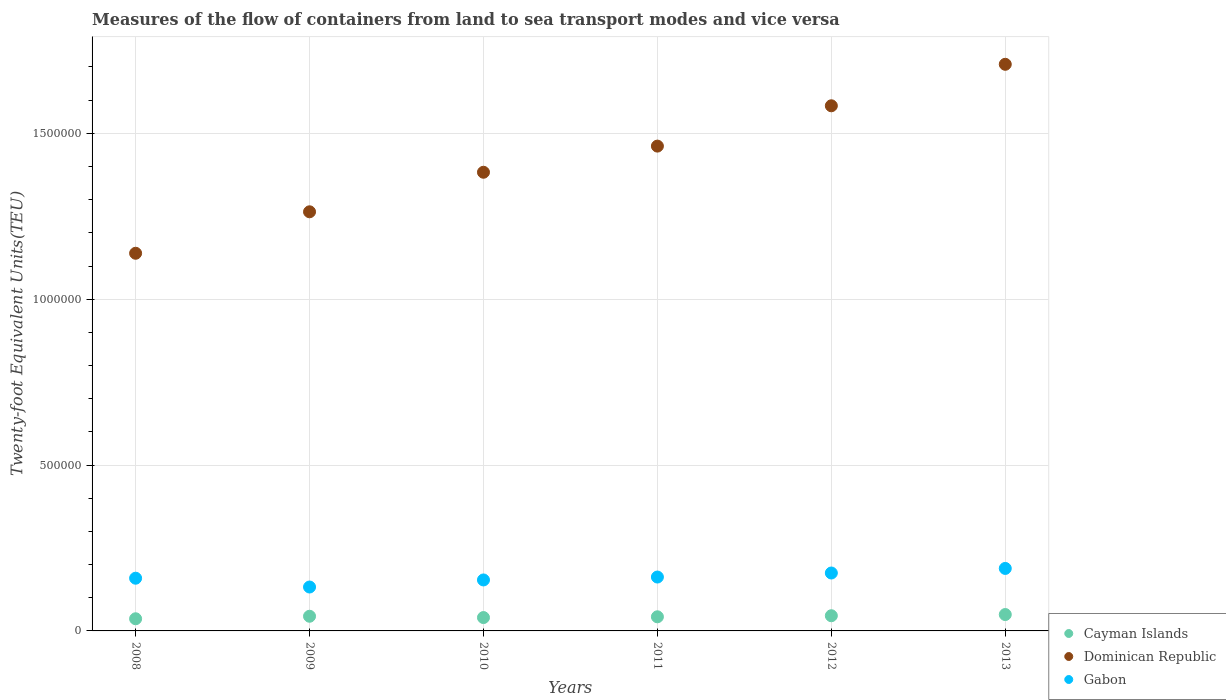How many different coloured dotlines are there?
Offer a very short reply. 3. Is the number of dotlines equal to the number of legend labels?
Offer a very short reply. Yes. What is the container port traffic in Cayman Islands in 2011?
Provide a succinct answer. 4.26e+04. Across all years, what is the maximum container port traffic in Gabon?
Keep it short and to the point. 1.88e+05. Across all years, what is the minimum container port traffic in Cayman Islands?
Provide a succinct answer. 3.66e+04. In which year was the container port traffic in Cayman Islands minimum?
Provide a succinct answer. 2008. What is the total container port traffic in Dominican Republic in the graph?
Your answer should be very brief. 8.54e+06. What is the difference between the container port traffic in Dominican Republic in 2009 and that in 2011?
Your answer should be very brief. -1.98e+05. What is the difference between the container port traffic in Dominican Republic in 2011 and the container port traffic in Cayman Islands in 2008?
Ensure brevity in your answer.  1.42e+06. What is the average container port traffic in Gabon per year?
Ensure brevity in your answer.  1.62e+05. In the year 2010, what is the difference between the container port traffic in Cayman Islands and container port traffic in Gabon?
Offer a terse response. -1.13e+05. What is the ratio of the container port traffic in Dominican Republic in 2010 to that in 2013?
Keep it short and to the point. 0.81. Is the container port traffic in Cayman Islands in 2008 less than that in 2010?
Offer a terse response. Yes. Is the difference between the container port traffic in Cayman Islands in 2008 and 2013 greater than the difference between the container port traffic in Gabon in 2008 and 2013?
Provide a short and direct response. Yes. What is the difference between the highest and the second highest container port traffic in Gabon?
Provide a short and direct response. 1.38e+04. What is the difference between the highest and the lowest container port traffic in Gabon?
Your answer should be compact. 5.60e+04. In how many years, is the container port traffic in Dominican Republic greater than the average container port traffic in Dominican Republic taken over all years?
Make the answer very short. 3. Is the sum of the container port traffic in Cayman Islands in 2011 and 2012 greater than the maximum container port traffic in Dominican Republic across all years?
Provide a short and direct response. No. Does the container port traffic in Dominican Republic monotonically increase over the years?
Make the answer very short. Yes. How many years are there in the graph?
Offer a very short reply. 6. What is the difference between two consecutive major ticks on the Y-axis?
Offer a terse response. 5.00e+05. Does the graph contain any zero values?
Offer a very short reply. No. Does the graph contain grids?
Give a very brief answer. Yes. How many legend labels are there?
Your answer should be very brief. 3. How are the legend labels stacked?
Keep it short and to the point. Vertical. What is the title of the graph?
Provide a short and direct response. Measures of the flow of containers from land to sea transport modes and vice versa. What is the label or title of the Y-axis?
Keep it short and to the point. Twenty-foot Equivalent Units(TEU). What is the Twenty-foot Equivalent Units(TEU) in Cayman Islands in 2008?
Your answer should be very brief. 3.66e+04. What is the Twenty-foot Equivalent Units(TEU) of Dominican Republic in 2008?
Make the answer very short. 1.14e+06. What is the Twenty-foot Equivalent Units(TEU) in Gabon in 2008?
Give a very brief answer. 1.59e+05. What is the Twenty-foot Equivalent Units(TEU) in Cayman Islands in 2009?
Your answer should be very brief. 4.42e+04. What is the Twenty-foot Equivalent Units(TEU) of Dominican Republic in 2009?
Your response must be concise. 1.26e+06. What is the Twenty-foot Equivalent Units(TEU) in Gabon in 2009?
Offer a very short reply. 1.32e+05. What is the Twenty-foot Equivalent Units(TEU) of Cayman Islands in 2010?
Offer a terse response. 4.03e+04. What is the Twenty-foot Equivalent Units(TEU) of Dominican Republic in 2010?
Make the answer very short. 1.38e+06. What is the Twenty-foot Equivalent Units(TEU) of Gabon in 2010?
Keep it short and to the point. 1.54e+05. What is the Twenty-foot Equivalent Units(TEU) in Cayman Islands in 2011?
Offer a terse response. 4.26e+04. What is the Twenty-foot Equivalent Units(TEU) of Dominican Republic in 2011?
Give a very brief answer. 1.46e+06. What is the Twenty-foot Equivalent Units(TEU) of Gabon in 2011?
Offer a very short reply. 1.62e+05. What is the Twenty-foot Equivalent Units(TEU) of Cayman Islands in 2012?
Your response must be concise. 4.58e+04. What is the Twenty-foot Equivalent Units(TEU) in Dominican Republic in 2012?
Ensure brevity in your answer.  1.58e+06. What is the Twenty-foot Equivalent Units(TEU) in Gabon in 2012?
Keep it short and to the point. 1.75e+05. What is the Twenty-foot Equivalent Units(TEU) in Cayman Islands in 2013?
Your answer should be very brief. 4.94e+04. What is the Twenty-foot Equivalent Units(TEU) in Dominican Republic in 2013?
Provide a short and direct response. 1.71e+06. What is the Twenty-foot Equivalent Units(TEU) in Gabon in 2013?
Offer a very short reply. 1.88e+05. Across all years, what is the maximum Twenty-foot Equivalent Units(TEU) in Cayman Islands?
Provide a succinct answer. 4.94e+04. Across all years, what is the maximum Twenty-foot Equivalent Units(TEU) of Dominican Republic?
Give a very brief answer. 1.71e+06. Across all years, what is the maximum Twenty-foot Equivalent Units(TEU) in Gabon?
Provide a short and direct response. 1.88e+05. Across all years, what is the minimum Twenty-foot Equivalent Units(TEU) in Cayman Islands?
Give a very brief answer. 3.66e+04. Across all years, what is the minimum Twenty-foot Equivalent Units(TEU) in Dominican Republic?
Your answer should be very brief. 1.14e+06. Across all years, what is the minimum Twenty-foot Equivalent Units(TEU) in Gabon?
Make the answer very short. 1.32e+05. What is the total Twenty-foot Equivalent Units(TEU) in Cayman Islands in the graph?
Provide a succinct answer. 2.59e+05. What is the total Twenty-foot Equivalent Units(TEU) in Dominican Republic in the graph?
Offer a terse response. 8.54e+06. What is the total Twenty-foot Equivalent Units(TEU) in Gabon in the graph?
Keep it short and to the point. 9.70e+05. What is the difference between the Twenty-foot Equivalent Units(TEU) of Cayman Islands in 2008 and that in 2009?
Your response must be concise. -7571. What is the difference between the Twenty-foot Equivalent Units(TEU) in Dominican Republic in 2008 and that in 2009?
Offer a terse response. -1.25e+05. What is the difference between the Twenty-foot Equivalent Units(TEU) of Gabon in 2008 and that in 2009?
Make the answer very short. 2.65e+04. What is the difference between the Twenty-foot Equivalent Units(TEU) of Cayman Islands in 2008 and that in 2010?
Offer a terse response. -3637. What is the difference between the Twenty-foot Equivalent Units(TEU) in Dominican Republic in 2008 and that in 2010?
Keep it short and to the point. -2.44e+05. What is the difference between the Twenty-foot Equivalent Units(TEU) of Gabon in 2008 and that in 2010?
Provide a short and direct response. 5227.04. What is the difference between the Twenty-foot Equivalent Units(TEU) of Cayman Islands in 2008 and that in 2011?
Your answer should be compact. -5933. What is the difference between the Twenty-foot Equivalent Units(TEU) of Dominican Republic in 2008 and that in 2011?
Your answer should be compact. -3.23e+05. What is the difference between the Twenty-foot Equivalent Units(TEU) in Gabon in 2008 and that in 2011?
Ensure brevity in your answer.  -3531.4. What is the difference between the Twenty-foot Equivalent Units(TEU) in Cayman Islands in 2008 and that in 2012?
Provide a short and direct response. -9126.27. What is the difference between the Twenty-foot Equivalent Units(TEU) in Dominican Republic in 2008 and that in 2012?
Make the answer very short. -4.45e+05. What is the difference between the Twenty-foot Equivalent Units(TEU) of Gabon in 2008 and that in 2012?
Your response must be concise. -1.57e+04. What is the difference between the Twenty-foot Equivalent Units(TEU) in Cayman Islands in 2008 and that in 2013?
Make the answer very short. -1.27e+04. What is the difference between the Twenty-foot Equivalent Units(TEU) in Dominican Republic in 2008 and that in 2013?
Provide a succinct answer. -5.70e+05. What is the difference between the Twenty-foot Equivalent Units(TEU) in Gabon in 2008 and that in 2013?
Give a very brief answer. -2.95e+04. What is the difference between the Twenty-foot Equivalent Units(TEU) of Cayman Islands in 2009 and that in 2010?
Your answer should be compact. 3934. What is the difference between the Twenty-foot Equivalent Units(TEU) in Dominican Republic in 2009 and that in 2010?
Your answer should be compact. -1.19e+05. What is the difference between the Twenty-foot Equivalent Units(TEU) in Gabon in 2009 and that in 2010?
Provide a short and direct response. -2.13e+04. What is the difference between the Twenty-foot Equivalent Units(TEU) in Cayman Islands in 2009 and that in 2011?
Your answer should be compact. 1638. What is the difference between the Twenty-foot Equivalent Units(TEU) in Dominican Republic in 2009 and that in 2011?
Offer a very short reply. -1.98e+05. What is the difference between the Twenty-foot Equivalent Units(TEU) in Gabon in 2009 and that in 2011?
Offer a terse response. -3.01e+04. What is the difference between the Twenty-foot Equivalent Units(TEU) of Cayman Islands in 2009 and that in 2012?
Offer a terse response. -1555.28. What is the difference between the Twenty-foot Equivalent Units(TEU) in Dominican Republic in 2009 and that in 2012?
Offer a terse response. -3.20e+05. What is the difference between the Twenty-foot Equivalent Units(TEU) of Gabon in 2009 and that in 2012?
Give a very brief answer. -4.22e+04. What is the difference between the Twenty-foot Equivalent Units(TEU) in Cayman Islands in 2009 and that in 2013?
Provide a succinct answer. -5171.13. What is the difference between the Twenty-foot Equivalent Units(TEU) of Dominican Republic in 2009 and that in 2013?
Offer a very short reply. -4.45e+05. What is the difference between the Twenty-foot Equivalent Units(TEU) of Gabon in 2009 and that in 2013?
Make the answer very short. -5.60e+04. What is the difference between the Twenty-foot Equivalent Units(TEU) of Cayman Islands in 2010 and that in 2011?
Provide a succinct answer. -2296. What is the difference between the Twenty-foot Equivalent Units(TEU) of Dominican Republic in 2010 and that in 2011?
Offer a terse response. -7.88e+04. What is the difference between the Twenty-foot Equivalent Units(TEU) in Gabon in 2010 and that in 2011?
Give a very brief answer. -8758.45. What is the difference between the Twenty-foot Equivalent Units(TEU) of Cayman Islands in 2010 and that in 2012?
Offer a terse response. -5489.27. What is the difference between the Twenty-foot Equivalent Units(TEU) in Dominican Republic in 2010 and that in 2012?
Provide a succinct answer. -2.00e+05. What is the difference between the Twenty-foot Equivalent Units(TEU) of Gabon in 2010 and that in 2012?
Your response must be concise. -2.09e+04. What is the difference between the Twenty-foot Equivalent Units(TEU) of Cayman Islands in 2010 and that in 2013?
Your answer should be compact. -9105.13. What is the difference between the Twenty-foot Equivalent Units(TEU) in Dominican Republic in 2010 and that in 2013?
Make the answer very short. -3.25e+05. What is the difference between the Twenty-foot Equivalent Units(TEU) of Gabon in 2010 and that in 2013?
Provide a succinct answer. -3.47e+04. What is the difference between the Twenty-foot Equivalent Units(TEU) of Cayman Islands in 2011 and that in 2012?
Offer a very short reply. -3193.28. What is the difference between the Twenty-foot Equivalent Units(TEU) in Dominican Republic in 2011 and that in 2012?
Your answer should be compact. -1.22e+05. What is the difference between the Twenty-foot Equivalent Units(TEU) in Gabon in 2011 and that in 2012?
Provide a succinct answer. -1.22e+04. What is the difference between the Twenty-foot Equivalent Units(TEU) of Cayman Islands in 2011 and that in 2013?
Make the answer very short. -6809.13. What is the difference between the Twenty-foot Equivalent Units(TEU) in Dominican Republic in 2011 and that in 2013?
Your answer should be very brief. -2.47e+05. What is the difference between the Twenty-foot Equivalent Units(TEU) of Gabon in 2011 and that in 2013?
Keep it short and to the point. -2.60e+04. What is the difference between the Twenty-foot Equivalent Units(TEU) in Cayman Islands in 2012 and that in 2013?
Your response must be concise. -3615.85. What is the difference between the Twenty-foot Equivalent Units(TEU) of Dominican Republic in 2012 and that in 2013?
Your response must be concise. -1.25e+05. What is the difference between the Twenty-foot Equivalent Units(TEU) of Gabon in 2012 and that in 2013?
Keep it short and to the point. -1.38e+04. What is the difference between the Twenty-foot Equivalent Units(TEU) of Cayman Islands in 2008 and the Twenty-foot Equivalent Units(TEU) of Dominican Republic in 2009?
Ensure brevity in your answer.  -1.23e+06. What is the difference between the Twenty-foot Equivalent Units(TEU) in Cayman Islands in 2008 and the Twenty-foot Equivalent Units(TEU) in Gabon in 2009?
Make the answer very short. -9.57e+04. What is the difference between the Twenty-foot Equivalent Units(TEU) of Dominican Republic in 2008 and the Twenty-foot Equivalent Units(TEU) of Gabon in 2009?
Keep it short and to the point. 1.01e+06. What is the difference between the Twenty-foot Equivalent Units(TEU) in Cayman Islands in 2008 and the Twenty-foot Equivalent Units(TEU) in Dominican Republic in 2010?
Your answer should be compact. -1.35e+06. What is the difference between the Twenty-foot Equivalent Units(TEU) of Cayman Islands in 2008 and the Twenty-foot Equivalent Units(TEU) of Gabon in 2010?
Give a very brief answer. -1.17e+05. What is the difference between the Twenty-foot Equivalent Units(TEU) in Dominican Republic in 2008 and the Twenty-foot Equivalent Units(TEU) in Gabon in 2010?
Provide a succinct answer. 9.85e+05. What is the difference between the Twenty-foot Equivalent Units(TEU) in Cayman Islands in 2008 and the Twenty-foot Equivalent Units(TEU) in Dominican Republic in 2011?
Ensure brevity in your answer.  -1.42e+06. What is the difference between the Twenty-foot Equivalent Units(TEU) of Cayman Islands in 2008 and the Twenty-foot Equivalent Units(TEU) of Gabon in 2011?
Make the answer very short. -1.26e+05. What is the difference between the Twenty-foot Equivalent Units(TEU) in Dominican Republic in 2008 and the Twenty-foot Equivalent Units(TEU) in Gabon in 2011?
Give a very brief answer. 9.76e+05. What is the difference between the Twenty-foot Equivalent Units(TEU) in Cayman Islands in 2008 and the Twenty-foot Equivalent Units(TEU) in Dominican Republic in 2012?
Make the answer very short. -1.55e+06. What is the difference between the Twenty-foot Equivalent Units(TEU) in Cayman Islands in 2008 and the Twenty-foot Equivalent Units(TEU) in Gabon in 2012?
Provide a short and direct response. -1.38e+05. What is the difference between the Twenty-foot Equivalent Units(TEU) of Dominican Republic in 2008 and the Twenty-foot Equivalent Units(TEU) of Gabon in 2012?
Make the answer very short. 9.64e+05. What is the difference between the Twenty-foot Equivalent Units(TEU) of Cayman Islands in 2008 and the Twenty-foot Equivalent Units(TEU) of Dominican Republic in 2013?
Your answer should be very brief. -1.67e+06. What is the difference between the Twenty-foot Equivalent Units(TEU) in Cayman Islands in 2008 and the Twenty-foot Equivalent Units(TEU) in Gabon in 2013?
Make the answer very short. -1.52e+05. What is the difference between the Twenty-foot Equivalent Units(TEU) in Dominican Republic in 2008 and the Twenty-foot Equivalent Units(TEU) in Gabon in 2013?
Give a very brief answer. 9.50e+05. What is the difference between the Twenty-foot Equivalent Units(TEU) in Cayman Islands in 2009 and the Twenty-foot Equivalent Units(TEU) in Dominican Republic in 2010?
Ensure brevity in your answer.  -1.34e+06. What is the difference between the Twenty-foot Equivalent Units(TEU) of Cayman Islands in 2009 and the Twenty-foot Equivalent Units(TEU) of Gabon in 2010?
Your answer should be compact. -1.09e+05. What is the difference between the Twenty-foot Equivalent Units(TEU) of Dominican Republic in 2009 and the Twenty-foot Equivalent Units(TEU) of Gabon in 2010?
Offer a very short reply. 1.11e+06. What is the difference between the Twenty-foot Equivalent Units(TEU) of Cayman Islands in 2009 and the Twenty-foot Equivalent Units(TEU) of Dominican Republic in 2011?
Offer a terse response. -1.42e+06. What is the difference between the Twenty-foot Equivalent Units(TEU) of Cayman Islands in 2009 and the Twenty-foot Equivalent Units(TEU) of Gabon in 2011?
Provide a short and direct response. -1.18e+05. What is the difference between the Twenty-foot Equivalent Units(TEU) of Dominican Republic in 2009 and the Twenty-foot Equivalent Units(TEU) of Gabon in 2011?
Your response must be concise. 1.10e+06. What is the difference between the Twenty-foot Equivalent Units(TEU) of Cayman Islands in 2009 and the Twenty-foot Equivalent Units(TEU) of Dominican Republic in 2012?
Offer a very short reply. -1.54e+06. What is the difference between the Twenty-foot Equivalent Units(TEU) in Cayman Islands in 2009 and the Twenty-foot Equivalent Units(TEU) in Gabon in 2012?
Provide a succinct answer. -1.30e+05. What is the difference between the Twenty-foot Equivalent Units(TEU) in Dominican Republic in 2009 and the Twenty-foot Equivalent Units(TEU) in Gabon in 2012?
Your answer should be very brief. 1.09e+06. What is the difference between the Twenty-foot Equivalent Units(TEU) in Cayman Islands in 2009 and the Twenty-foot Equivalent Units(TEU) in Dominican Republic in 2013?
Make the answer very short. -1.66e+06. What is the difference between the Twenty-foot Equivalent Units(TEU) in Cayman Islands in 2009 and the Twenty-foot Equivalent Units(TEU) in Gabon in 2013?
Your response must be concise. -1.44e+05. What is the difference between the Twenty-foot Equivalent Units(TEU) in Dominican Republic in 2009 and the Twenty-foot Equivalent Units(TEU) in Gabon in 2013?
Offer a very short reply. 1.08e+06. What is the difference between the Twenty-foot Equivalent Units(TEU) in Cayman Islands in 2010 and the Twenty-foot Equivalent Units(TEU) in Dominican Republic in 2011?
Ensure brevity in your answer.  -1.42e+06. What is the difference between the Twenty-foot Equivalent Units(TEU) in Cayman Islands in 2010 and the Twenty-foot Equivalent Units(TEU) in Gabon in 2011?
Keep it short and to the point. -1.22e+05. What is the difference between the Twenty-foot Equivalent Units(TEU) in Dominican Republic in 2010 and the Twenty-foot Equivalent Units(TEU) in Gabon in 2011?
Provide a succinct answer. 1.22e+06. What is the difference between the Twenty-foot Equivalent Units(TEU) in Cayman Islands in 2010 and the Twenty-foot Equivalent Units(TEU) in Dominican Republic in 2012?
Provide a short and direct response. -1.54e+06. What is the difference between the Twenty-foot Equivalent Units(TEU) of Cayman Islands in 2010 and the Twenty-foot Equivalent Units(TEU) of Gabon in 2012?
Keep it short and to the point. -1.34e+05. What is the difference between the Twenty-foot Equivalent Units(TEU) of Dominican Republic in 2010 and the Twenty-foot Equivalent Units(TEU) of Gabon in 2012?
Provide a short and direct response. 1.21e+06. What is the difference between the Twenty-foot Equivalent Units(TEU) in Cayman Islands in 2010 and the Twenty-foot Equivalent Units(TEU) in Dominican Republic in 2013?
Make the answer very short. -1.67e+06. What is the difference between the Twenty-foot Equivalent Units(TEU) in Cayman Islands in 2010 and the Twenty-foot Equivalent Units(TEU) in Gabon in 2013?
Provide a succinct answer. -1.48e+05. What is the difference between the Twenty-foot Equivalent Units(TEU) of Dominican Republic in 2010 and the Twenty-foot Equivalent Units(TEU) of Gabon in 2013?
Offer a terse response. 1.19e+06. What is the difference between the Twenty-foot Equivalent Units(TEU) in Cayman Islands in 2011 and the Twenty-foot Equivalent Units(TEU) in Dominican Republic in 2012?
Offer a very short reply. -1.54e+06. What is the difference between the Twenty-foot Equivalent Units(TEU) of Cayman Islands in 2011 and the Twenty-foot Equivalent Units(TEU) of Gabon in 2012?
Give a very brief answer. -1.32e+05. What is the difference between the Twenty-foot Equivalent Units(TEU) of Dominican Republic in 2011 and the Twenty-foot Equivalent Units(TEU) of Gabon in 2012?
Ensure brevity in your answer.  1.29e+06. What is the difference between the Twenty-foot Equivalent Units(TEU) of Cayman Islands in 2011 and the Twenty-foot Equivalent Units(TEU) of Dominican Republic in 2013?
Your answer should be compact. -1.67e+06. What is the difference between the Twenty-foot Equivalent Units(TEU) in Cayman Islands in 2011 and the Twenty-foot Equivalent Units(TEU) in Gabon in 2013?
Offer a terse response. -1.46e+05. What is the difference between the Twenty-foot Equivalent Units(TEU) of Dominican Republic in 2011 and the Twenty-foot Equivalent Units(TEU) of Gabon in 2013?
Keep it short and to the point. 1.27e+06. What is the difference between the Twenty-foot Equivalent Units(TEU) of Cayman Islands in 2012 and the Twenty-foot Equivalent Units(TEU) of Dominican Republic in 2013?
Make the answer very short. -1.66e+06. What is the difference between the Twenty-foot Equivalent Units(TEU) in Cayman Islands in 2012 and the Twenty-foot Equivalent Units(TEU) in Gabon in 2013?
Provide a short and direct response. -1.43e+05. What is the difference between the Twenty-foot Equivalent Units(TEU) in Dominican Republic in 2012 and the Twenty-foot Equivalent Units(TEU) in Gabon in 2013?
Offer a very short reply. 1.39e+06. What is the average Twenty-foot Equivalent Units(TEU) in Cayman Islands per year?
Make the answer very short. 4.31e+04. What is the average Twenty-foot Equivalent Units(TEU) in Dominican Republic per year?
Offer a very short reply. 1.42e+06. What is the average Twenty-foot Equivalent Units(TEU) of Gabon per year?
Provide a succinct answer. 1.62e+05. In the year 2008, what is the difference between the Twenty-foot Equivalent Units(TEU) in Cayman Islands and Twenty-foot Equivalent Units(TEU) in Dominican Republic?
Your answer should be very brief. -1.10e+06. In the year 2008, what is the difference between the Twenty-foot Equivalent Units(TEU) of Cayman Islands and Twenty-foot Equivalent Units(TEU) of Gabon?
Keep it short and to the point. -1.22e+05. In the year 2008, what is the difference between the Twenty-foot Equivalent Units(TEU) of Dominican Republic and Twenty-foot Equivalent Units(TEU) of Gabon?
Keep it short and to the point. 9.80e+05. In the year 2009, what is the difference between the Twenty-foot Equivalent Units(TEU) of Cayman Islands and Twenty-foot Equivalent Units(TEU) of Dominican Republic?
Provide a succinct answer. -1.22e+06. In the year 2009, what is the difference between the Twenty-foot Equivalent Units(TEU) of Cayman Islands and Twenty-foot Equivalent Units(TEU) of Gabon?
Your answer should be compact. -8.81e+04. In the year 2009, what is the difference between the Twenty-foot Equivalent Units(TEU) of Dominican Republic and Twenty-foot Equivalent Units(TEU) of Gabon?
Make the answer very short. 1.13e+06. In the year 2010, what is the difference between the Twenty-foot Equivalent Units(TEU) of Cayman Islands and Twenty-foot Equivalent Units(TEU) of Dominican Republic?
Ensure brevity in your answer.  -1.34e+06. In the year 2010, what is the difference between the Twenty-foot Equivalent Units(TEU) in Cayman Islands and Twenty-foot Equivalent Units(TEU) in Gabon?
Your answer should be very brief. -1.13e+05. In the year 2010, what is the difference between the Twenty-foot Equivalent Units(TEU) in Dominican Republic and Twenty-foot Equivalent Units(TEU) in Gabon?
Make the answer very short. 1.23e+06. In the year 2011, what is the difference between the Twenty-foot Equivalent Units(TEU) in Cayman Islands and Twenty-foot Equivalent Units(TEU) in Dominican Republic?
Ensure brevity in your answer.  -1.42e+06. In the year 2011, what is the difference between the Twenty-foot Equivalent Units(TEU) in Cayman Islands and Twenty-foot Equivalent Units(TEU) in Gabon?
Provide a short and direct response. -1.20e+05. In the year 2011, what is the difference between the Twenty-foot Equivalent Units(TEU) in Dominican Republic and Twenty-foot Equivalent Units(TEU) in Gabon?
Offer a very short reply. 1.30e+06. In the year 2012, what is the difference between the Twenty-foot Equivalent Units(TEU) of Cayman Islands and Twenty-foot Equivalent Units(TEU) of Dominican Republic?
Offer a very short reply. -1.54e+06. In the year 2012, what is the difference between the Twenty-foot Equivalent Units(TEU) in Cayman Islands and Twenty-foot Equivalent Units(TEU) in Gabon?
Make the answer very short. -1.29e+05. In the year 2012, what is the difference between the Twenty-foot Equivalent Units(TEU) in Dominican Republic and Twenty-foot Equivalent Units(TEU) in Gabon?
Provide a short and direct response. 1.41e+06. In the year 2013, what is the difference between the Twenty-foot Equivalent Units(TEU) in Cayman Islands and Twenty-foot Equivalent Units(TEU) in Dominican Republic?
Offer a very short reply. -1.66e+06. In the year 2013, what is the difference between the Twenty-foot Equivalent Units(TEU) of Cayman Islands and Twenty-foot Equivalent Units(TEU) of Gabon?
Ensure brevity in your answer.  -1.39e+05. In the year 2013, what is the difference between the Twenty-foot Equivalent Units(TEU) of Dominican Republic and Twenty-foot Equivalent Units(TEU) of Gabon?
Make the answer very short. 1.52e+06. What is the ratio of the Twenty-foot Equivalent Units(TEU) of Cayman Islands in 2008 to that in 2009?
Your answer should be very brief. 0.83. What is the ratio of the Twenty-foot Equivalent Units(TEU) in Dominican Republic in 2008 to that in 2009?
Make the answer very short. 0.9. What is the ratio of the Twenty-foot Equivalent Units(TEU) of Gabon in 2008 to that in 2009?
Your answer should be very brief. 1.2. What is the ratio of the Twenty-foot Equivalent Units(TEU) in Cayman Islands in 2008 to that in 2010?
Your answer should be compact. 0.91. What is the ratio of the Twenty-foot Equivalent Units(TEU) in Dominican Republic in 2008 to that in 2010?
Provide a succinct answer. 0.82. What is the ratio of the Twenty-foot Equivalent Units(TEU) of Gabon in 2008 to that in 2010?
Your response must be concise. 1.03. What is the ratio of the Twenty-foot Equivalent Units(TEU) in Cayman Islands in 2008 to that in 2011?
Provide a succinct answer. 0.86. What is the ratio of the Twenty-foot Equivalent Units(TEU) in Dominican Republic in 2008 to that in 2011?
Your answer should be very brief. 0.78. What is the ratio of the Twenty-foot Equivalent Units(TEU) of Gabon in 2008 to that in 2011?
Keep it short and to the point. 0.98. What is the ratio of the Twenty-foot Equivalent Units(TEU) of Cayman Islands in 2008 to that in 2012?
Your answer should be very brief. 0.8. What is the ratio of the Twenty-foot Equivalent Units(TEU) in Dominican Republic in 2008 to that in 2012?
Make the answer very short. 0.72. What is the ratio of the Twenty-foot Equivalent Units(TEU) in Gabon in 2008 to that in 2012?
Provide a short and direct response. 0.91. What is the ratio of the Twenty-foot Equivalent Units(TEU) of Cayman Islands in 2008 to that in 2013?
Offer a very short reply. 0.74. What is the ratio of the Twenty-foot Equivalent Units(TEU) in Dominican Republic in 2008 to that in 2013?
Offer a very short reply. 0.67. What is the ratio of the Twenty-foot Equivalent Units(TEU) in Gabon in 2008 to that in 2013?
Your answer should be very brief. 0.84. What is the ratio of the Twenty-foot Equivalent Units(TEU) in Cayman Islands in 2009 to that in 2010?
Ensure brevity in your answer.  1.1. What is the ratio of the Twenty-foot Equivalent Units(TEU) of Dominican Republic in 2009 to that in 2010?
Your answer should be compact. 0.91. What is the ratio of the Twenty-foot Equivalent Units(TEU) of Gabon in 2009 to that in 2010?
Keep it short and to the point. 0.86. What is the ratio of the Twenty-foot Equivalent Units(TEU) in Dominican Republic in 2009 to that in 2011?
Your answer should be very brief. 0.86. What is the ratio of the Twenty-foot Equivalent Units(TEU) of Gabon in 2009 to that in 2011?
Keep it short and to the point. 0.81. What is the ratio of the Twenty-foot Equivalent Units(TEU) in Cayman Islands in 2009 to that in 2012?
Give a very brief answer. 0.97. What is the ratio of the Twenty-foot Equivalent Units(TEU) of Dominican Republic in 2009 to that in 2012?
Keep it short and to the point. 0.8. What is the ratio of the Twenty-foot Equivalent Units(TEU) of Gabon in 2009 to that in 2012?
Provide a short and direct response. 0.76. What is the ratio of the Twenty-foot Equivalent Units(TEU) in Cayman Islands in 2009 to that in 2013?
Provide a short and direct response. 0.9. What is the ratio of the Twenty-foot Equivalent Units(TEU) in Dominican Republic in 2009 to that in 2013?
Your answer should be very brief. 0.74. What is the ratio of the Twenty-foot Equivalent Units(TEU) in Gabon in 2009 to that in 2013?
Offer a terse response. 0.7. What is the ratio of the Twenty-foot Equivalent Units(TEU) of Cayman Islands in 2010 to that in 2011?
Your answer should be compact. 0.95. What is the ratio of the Twenty-foot Equivalent Units(TEU) in Dominican Republic in 2010 to that in 2011?
Your answer should be very brief. 0.95. What is the ratio of the Twenty-foot Equivalent Units(TEU) of Gabon in 2010 to that in 2011?
Keep it short and to the point. 0.95. What is the ratio of the Twenty-foot Equivalent Units(TEU) of Cayman Islands in 2010 to that in 2012?
Offer a terse response. 0.88. What is the ratio of the Twenty-foot Equivalent Units(TEU) in Dominican Republic in 2010 to that in 2012?
Keep it short and to the point. 0.87. What is the ratio of the Twenty-foot Equivalent Units(TEU) in Gabon in 2010 to that in 2012?
Offer a very short reply. 0.88. What is the ratio of the Twenty-foot Equivalent Units(TEU) of Cayman Islands in 2010 to that in 2013?
Make the answer very short. 0.82. What is the ratio of the Twenty-foot Equivalent Units(TEU) of Dominican Republic in 2010 to that in 2013?
Provide a short and direct response. 0.81. What is the ratio of the Twenty-foot Equivalent Units(TEU) in Gabon in 2010 to that in 2013?
Provide a succinct answer. 0.82. What is the ratio of the Twenty-foot Equivalent Units(TEU) of Cayman Islands in 2011 to that in 2012?
Your answer should be very brief. 0.93. What is the ratio of the Twenty-foot Equivalent Units(TEU) of Dominican Republic in 2011 to that in 2012?
Provide a succinct answer. 0.92. What is the ratio of the Twenty-foot Equivalent Units(TEU) of Gabon in 2011 to that in 2012?
Make the answer very short. 0.93. What is the ratio of the Twenty-foot Equivalent Units(TEU) in Cayman Islands in 2011 to that in 2013?
Ensure brevity in your answer.  0.86. What is the ratio of the Twenty-foot Equivalent Units(TEU) of Dominican Republic in 2011 to that in 2013?
Provide a short and direct response. 0.86. What is the ratio of the Twenty-foot Equivalent Units(TEU) of Gabon in 2011 to that in 2013?
Your answer should be compact. 0.86. What is the ratio of the Twenty-foot Equivalent Units(TEU) of Cayman Islands in 2012 to that in 2013?
Offer a very short reply. 0.93. What is the ratio of the Twenty-foot Equivalent Units(TEU) in Dominican Republic in 2012 to that in 2013?
Keep it short and to the point. 0.93. What is the ratio of the Twenty-foot Equivalent Units(TEU) of Gabon in 2012 to that in 2013?
Your answer should be compact. 0.93. What is the difference between the highest and the second highest Twenty-foot Equivalent Units(TEU) in Cayman Islands?
Keep it short and to the point. 3615.85. What is the difference between the highest and the second highest Twenty-foot Equivalent Units(TEU) in Dominican Republic?
Give a very brief answer. 1.25e+05. What is the difference between the highest and the second highest Twenty-foot Equivalent Units(TEU) of Gabon?
Make the answer very short. 1.38e+04. What is the difference between the highest and the lowest Twenty-foot Equivalent Units(TEU) of Cayman Islands?
Your answer should be very brief. 1.27e+04. What is the difference between the highest and the lowest Twenty-foot Equivalent Units(TEU) of Dominican Republic?
Offer a terse response. 5.70e+05. What is the difference between the highest and the lowest Twenty-foot Equivalent Units(TEU) in Gabon?
Ensure brevity in your answer.  5.60e+04. 